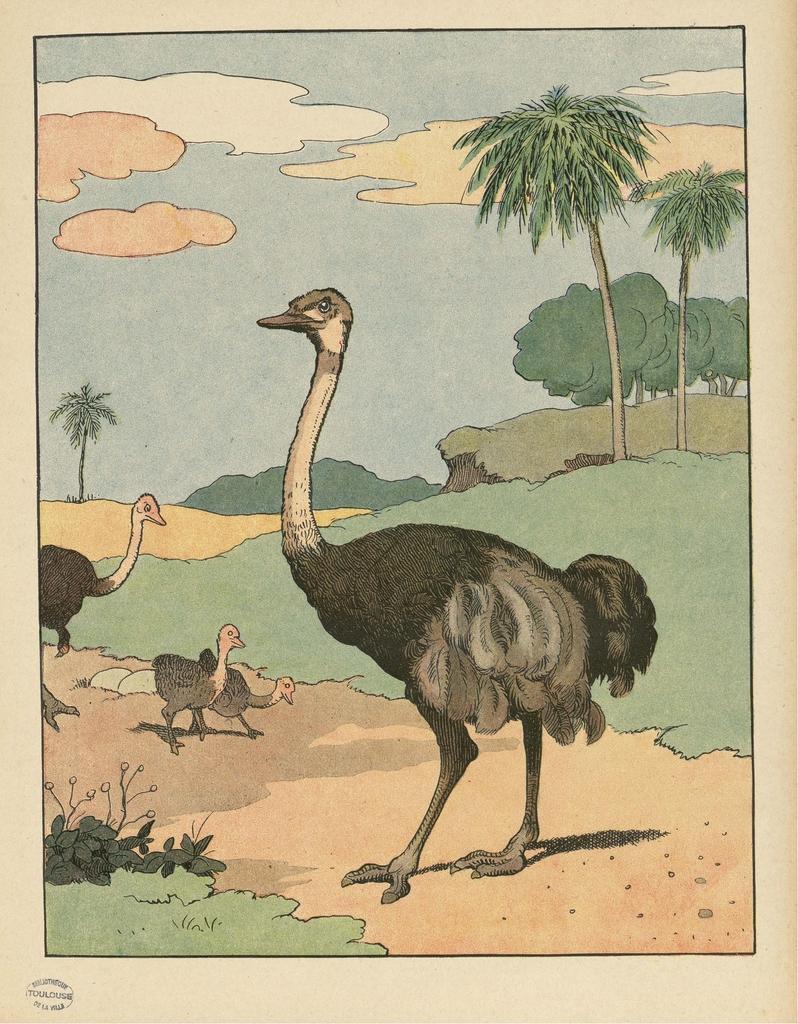Could you give a brief overview of what you see in this image? In this picture we can see birds, plants, trees, grass and the clouds in the sky. We can see the text and a few things in the bottom left. 